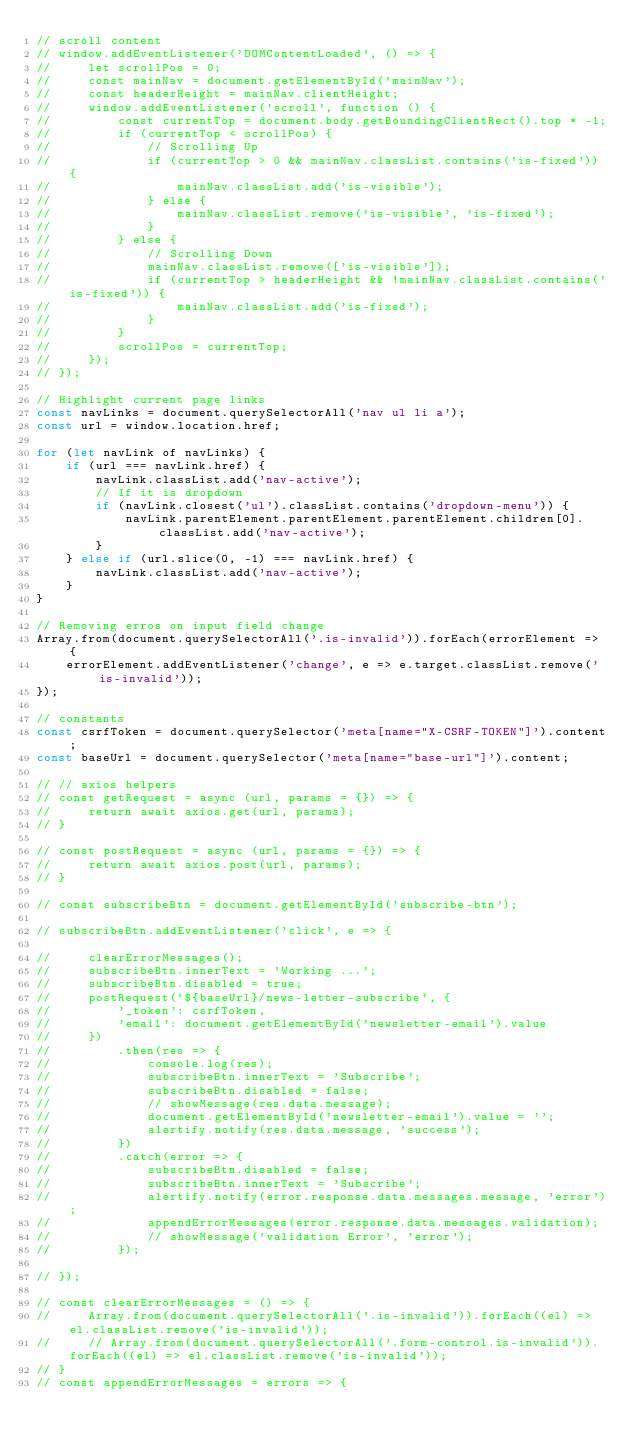<code> <loc_0><loc_0><loc_500><loc_500><_JavaScript_>// scroll content
// window.addEventListener('DOMContentLoaded', () => {
//     let scrollPos = 0;
//     const mainNav = document.getElementById('mainNav');
//     const headerHeight = mainNav.clientHeight;
//     window.addEventListener('scroll', function () {
//         const currentTop = document.body.getBoundingClientRect().top * -1;
//         if (currentTop < scrollPos) {
//             // Scrolling Up
//             if (currentTop > 0 && mainNav.classList.contains('is-fixed')) {
//                 mainNav.classList.add('is-visible');
//             } else {
//                 mainNav.classList.remove('is-visible', 'is-fixed');
//             }
//         } else {
//             // Scrolling Down
//             mainNav.classList.remove(['is-visible']);
//             if (currentTop > headerHeight && !mainNav.classList.contains('is-fixed')) {
//                 mainNav.classList.add('is-fixed');
//             }
//         }
//         scrollPos = currentTop;
//     });
// });

// Highlight current page links
const navLinks = document.querySelectorAll('nav ul li a');
const url = window.location.href;

for (let navLink of navLinks) {
    if (url === navLink.href) {
        navLink.classList.add('nav-active');
        // If it is dropdown
        if (navLink.closest('ul').classList.contains('dropdown-menu')) {
            navLink.parentElement.parentElement.parentElement.children[0].classList.add('nav-active');
        }
    } else if (url.slice(0, -1) === navLink.href) {
        navLink.classList.add('nav-active');
    }
}

// Removing erros on input field change
Array.from(document.querySelectorAll('.is-invalid')).forEach(errorElement => {
    errorElement.addEventListener('change', e => e.target.classList.remove('is-invalid'));
});

// constants
const csrfToken = document.querySelector('meta[name="X-CSRF-TOKEN"]').content;
const baseUrl = document.querySelector('meta[name="base-url"]').content;

// // axios helpers
// const getRequest = async (url, params = {}) => {
//     return await axios.get(url, params);
// }

// const postRequest = async (url, params = {}) => {
//     return await axios.post(url, params);
// }

// const subscribeBtn = document.getElementById('subscribe-btn');

// subscribeBtn.addEventListener('click', e => {

//     clearErrorMessages();
//     subscribeBtn.innerText = 'Working ...';
//     subscribeBtn.disabled = true;
//     postRequest(`${baseUrl}/news-letter-subscribe`, {
//         '_token': csrfToken,
//         'email': document.getElementById('newsletter-email').value
//     })
//         .then(res => {
//             console.log(res);
//             subscribeBtn.innerText = 'Subscribe';
//             subscribeBtn.disabled = false;
//             // showMessage(res.data.message);
//             document.getElementById('newsletter-email').value = '';
//             alertify.notify(res.data.message, 'success');
//         })
//         .catch(error => {
//             subscribeBtn.disabled = false;
//             subscribeBtn.innerText = 'Subscribe';
//             alertify.notify(error.response.data.messages.message, 'error');
//             appendErrorMessages(error.response.data.messages.validation);
//             // showMessage('validation Error', 'error');
//         });

// });

// const clearErrorMessages = () => {
//     Array.from(document.querySelectorAll('.is-invalid')).forEach((el) => el.classList.remove('is-invalid'));
//     // Array.from(document.querySelectorAll('.form-control.is-invalid')).forEach((el) => el.classList.remove('is-invalid'));
// }
// const appendErrorMessages = errors => {</code> 